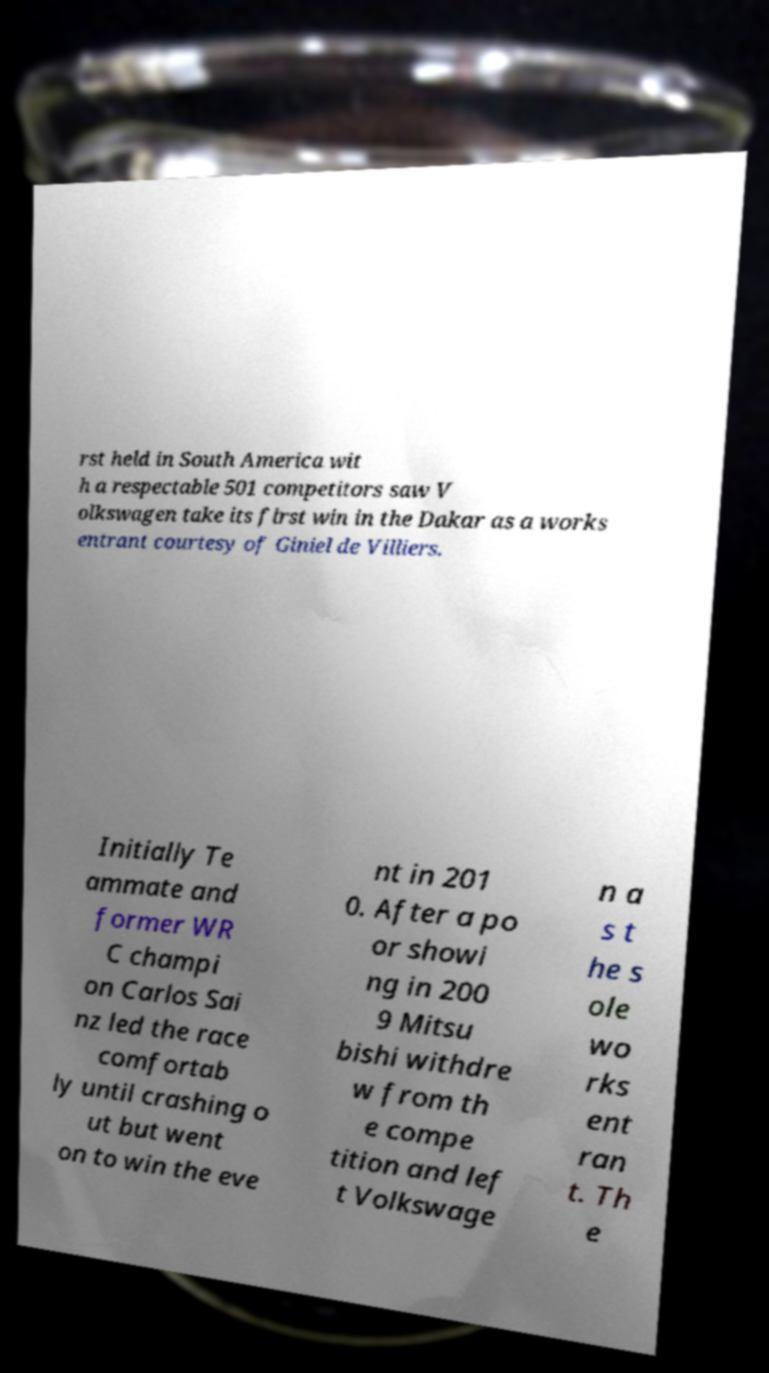For documentation purposes, I need the text within this image transcribed. Could you provide that? rst held in South America wit h a respectable 501 competitors saw V olkswagen take its first win in the Dakar as a works entrant courtesy of Giniel de Villiers. Initially Te ammate and former WR C champi on Carlos Sai nz led the race comfortab ly until crashing o ut but went on to win the eve nt in 201 0. After a po or showi ng in 200 9 Mitsu bishi withdre w from th e compe tition and lef t Volkswage n a s t he s ole wo rks ent ran t. Th e 